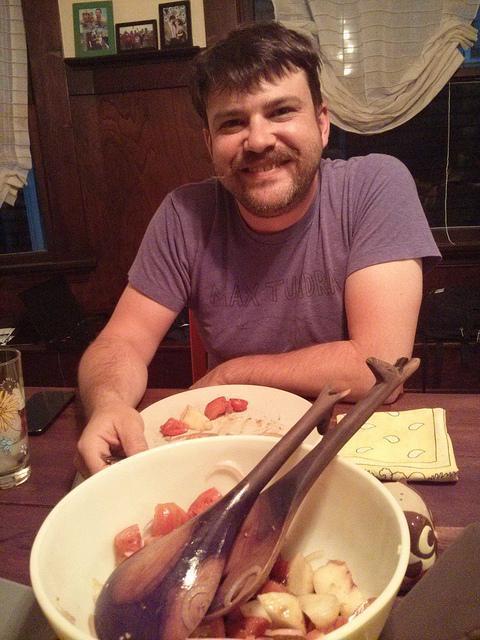How many spoons can be seen?
Give a very brief answer. 2. How many cups are there?
Give a very brief answer. 1. 